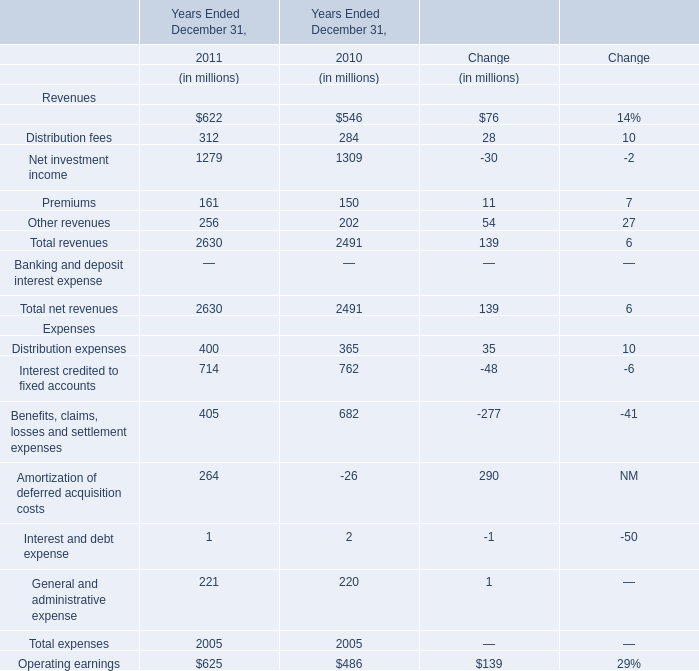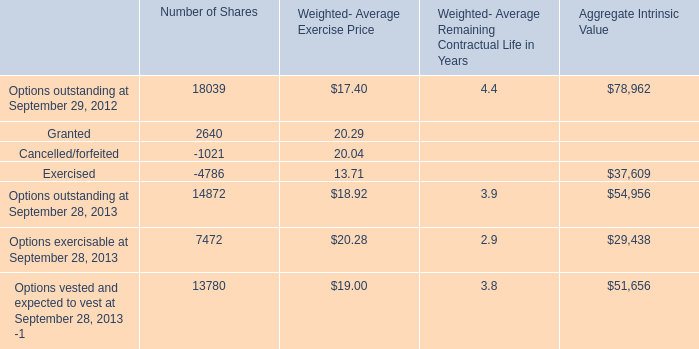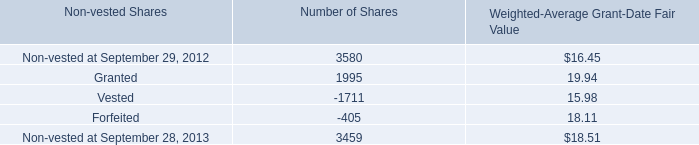How many kinds of Expenses staying in interval 500 million and 800 million in 2011 Ended December 31? 
Answer: 1. 